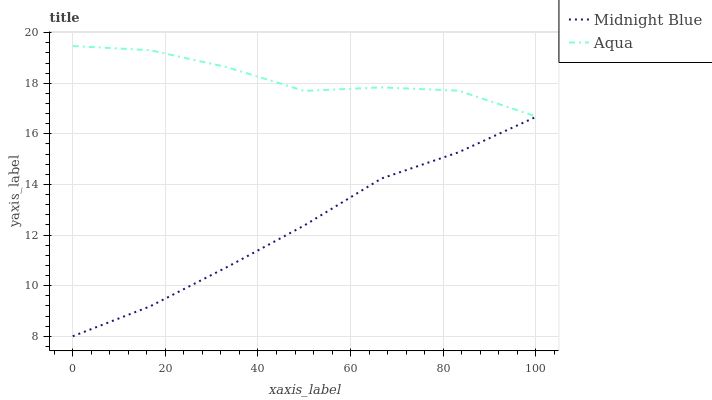Does Midnight Blue have the minimum area under the curve?
Answer yes or no. Yes. Does Aqua have the maximum area under the curve?
Answer yes or no. Yes. Does Midnight Blue have the maximum area under the curve?
Answer yes or no. No. Is Midnight Blue the smoothest?
Answer yes or no. Yes. Is Aqua the roughest?
Answer yes or no. Yes. Is Midnight Blue the roughest?
Answer yes or no. No. Does Midnight Blue have the lowest value?
Answer yes or no. Yes. Does Aqua have the highest value?
Answer yes or no. Yes. Does Midnight Blue have the highest value?
Answer yes or no. No. Is Midnight Blue less than Aqua?
Answer yes or no. Yes. Is Aqua greater than Midnight Blue?
Answer yes or no. Yes. Does Midnight Blue intersect Aqua?
Answer yes or no. No. 